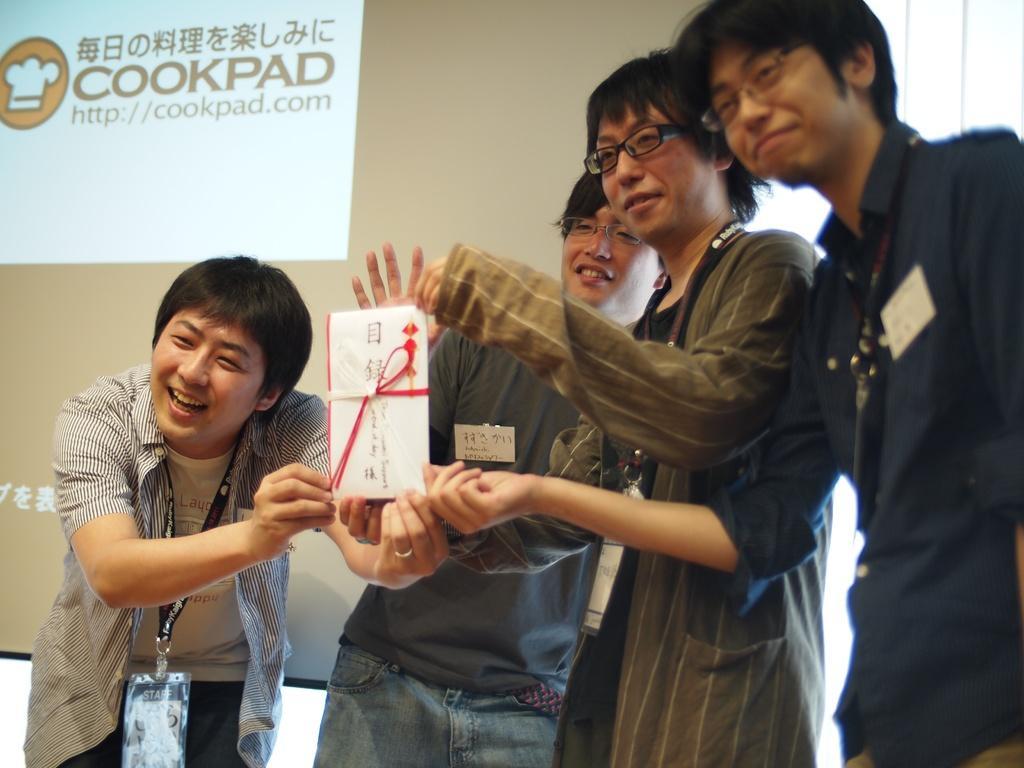Could you give a brief overview of what you see in this image? This image consists of four persons. And we can see four persons. And we can see a greeting in their hands. On the left, the person is wearing a tag. In the background, it looks like a screen. 